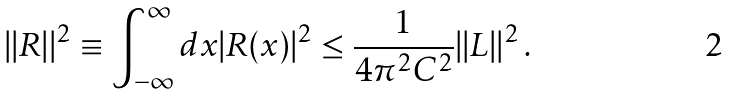Convert formula to latex. <formula><loc_0><loc_0><loc_500><loc_500>| | R | | ^ { 2 } \equiv \int _ { - \infty } ^ { \infty } d x | R ( x ) | ^ { 2 } \leq \frac { 1 } { 4 \pi ^ { 2 } C ^ { 2 } } | | L | | ^ { 2 } \, .</formula> 